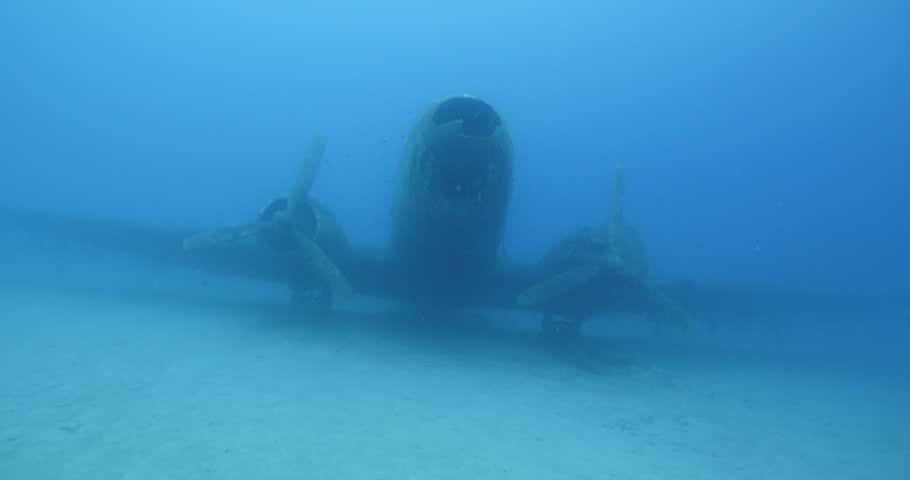Describe the condition of the airplane in the image. The airplane is clearly submerged and shows signs of being underwater for an extended period. It's an intriguing wreckage with algae and marine life starting to claim it as part of the ocean's ecosystem. 